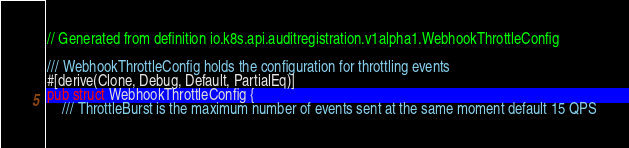Convert code to text. <code><loc_0><loc_0><loc_500><loc_500><_Rust_>// Generated from definition io.k8s.api.auditregistration.v1alpha1.WebhookThrottleConfig

/// WebhookThrottleConfig holds the configuration for throttling events
#[derive(Clone, Debug, Default, PartialEq)]
pub struct WebhookThrottleConfig {
    /// ThrottleBurst is the maximum number of events sent at the same moment default 15 QPS</code> 